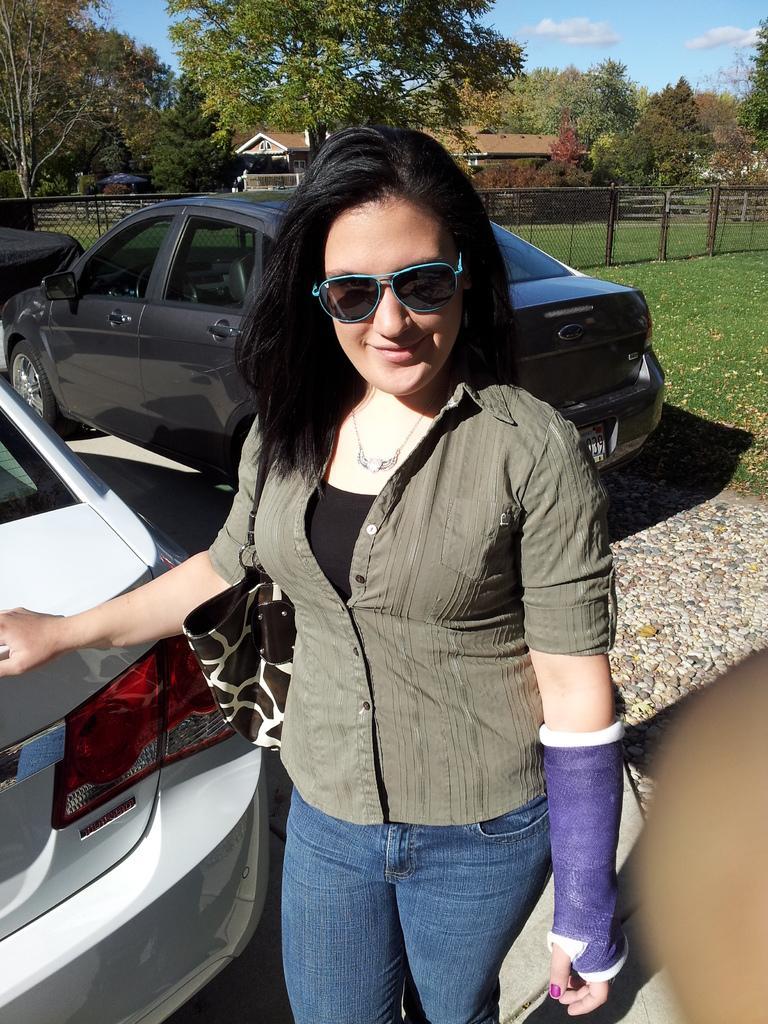Could you give a brief overview of what you see in this image? This image is clicked outside. There are cars in the middle. There is a person standing in the middle. She is wearing goggles. She has some bandage to her hand. There are trees at the top. There are buildings at the top. There is sky at the top. There is a fence in the middle. 